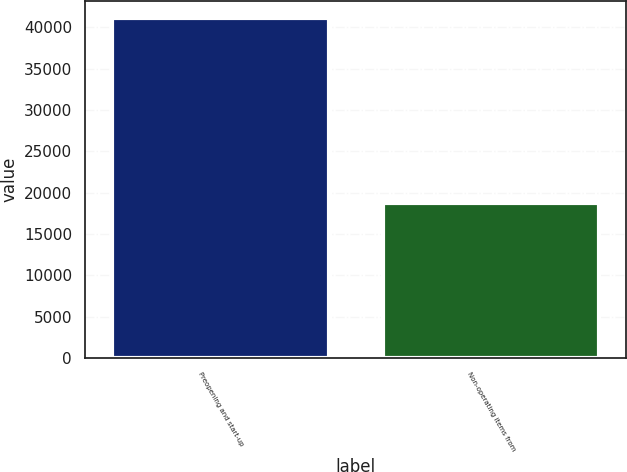Convert chart to OTSL. <chart><loc_0><loc_0><loc_500><loc_500><bar_chart><fcel>Preopening and start-up<fcel>Non-operating items from<nl><fcel>41140<fcel>18805<nl></chart> 